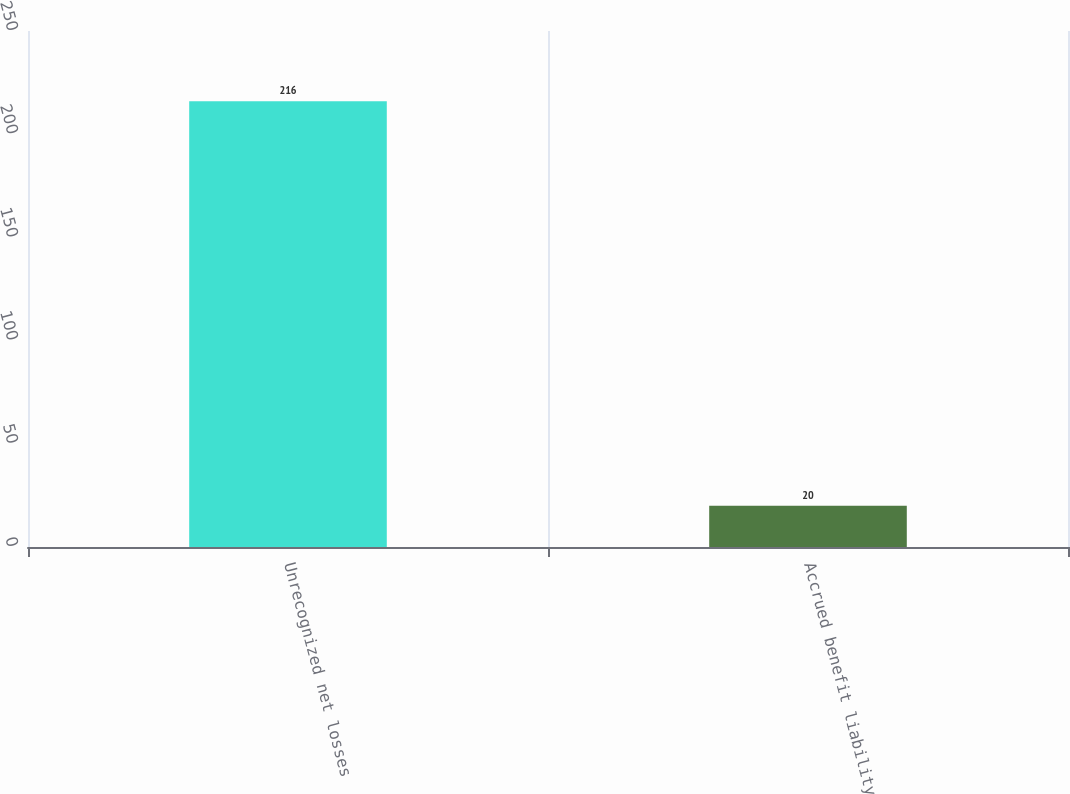Convert chart. <chart><loc_0><loc_0><loc_500><loc_500><bar_chart><fcel>Unrecognized net losses<fcel>Accrued benefit liability<nl><fcel>216<fcel>20<nl></chart> 